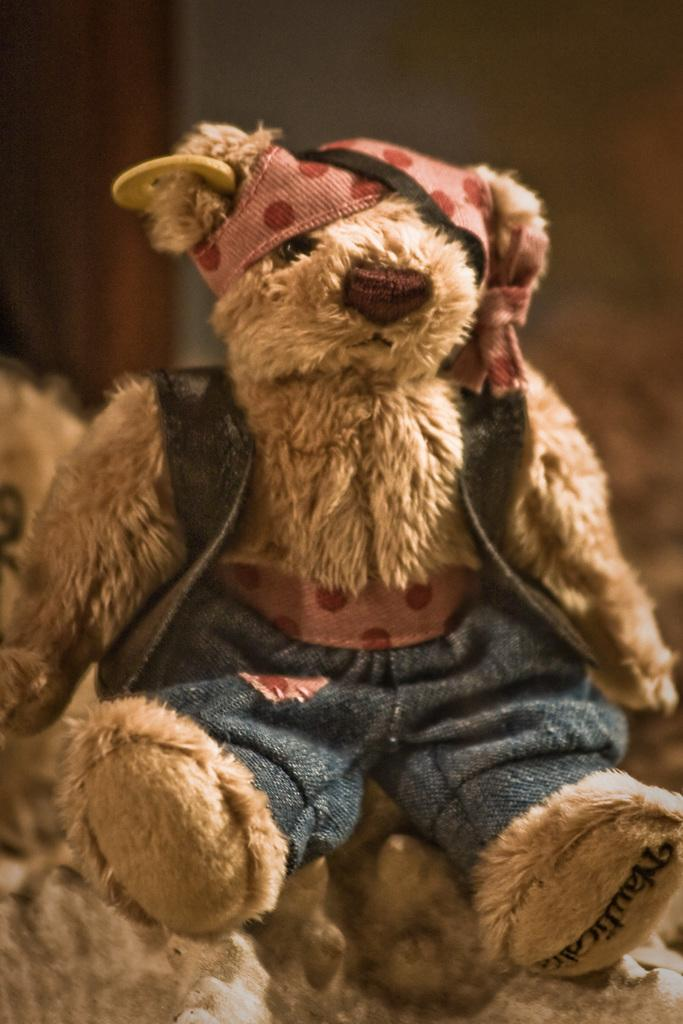What type of toy is present in the image? There is a teddy bear in the image. What color is the teddy bear? The teddy bear is brown in color. How much does the quarter cost in the image? There is no quarter present in the image, so it is not possible to determine its cost. 